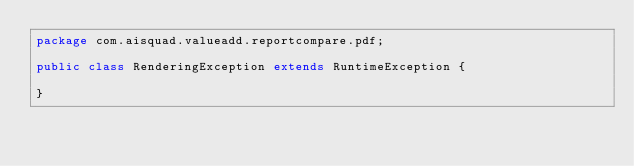<code> <loc_0><loc_0><loc_500><loc_500><_Java_>package com.aisquad.valueadd.reportcompare.pdf;

public class RenderingException extends RuntimeException {

}
</code> 